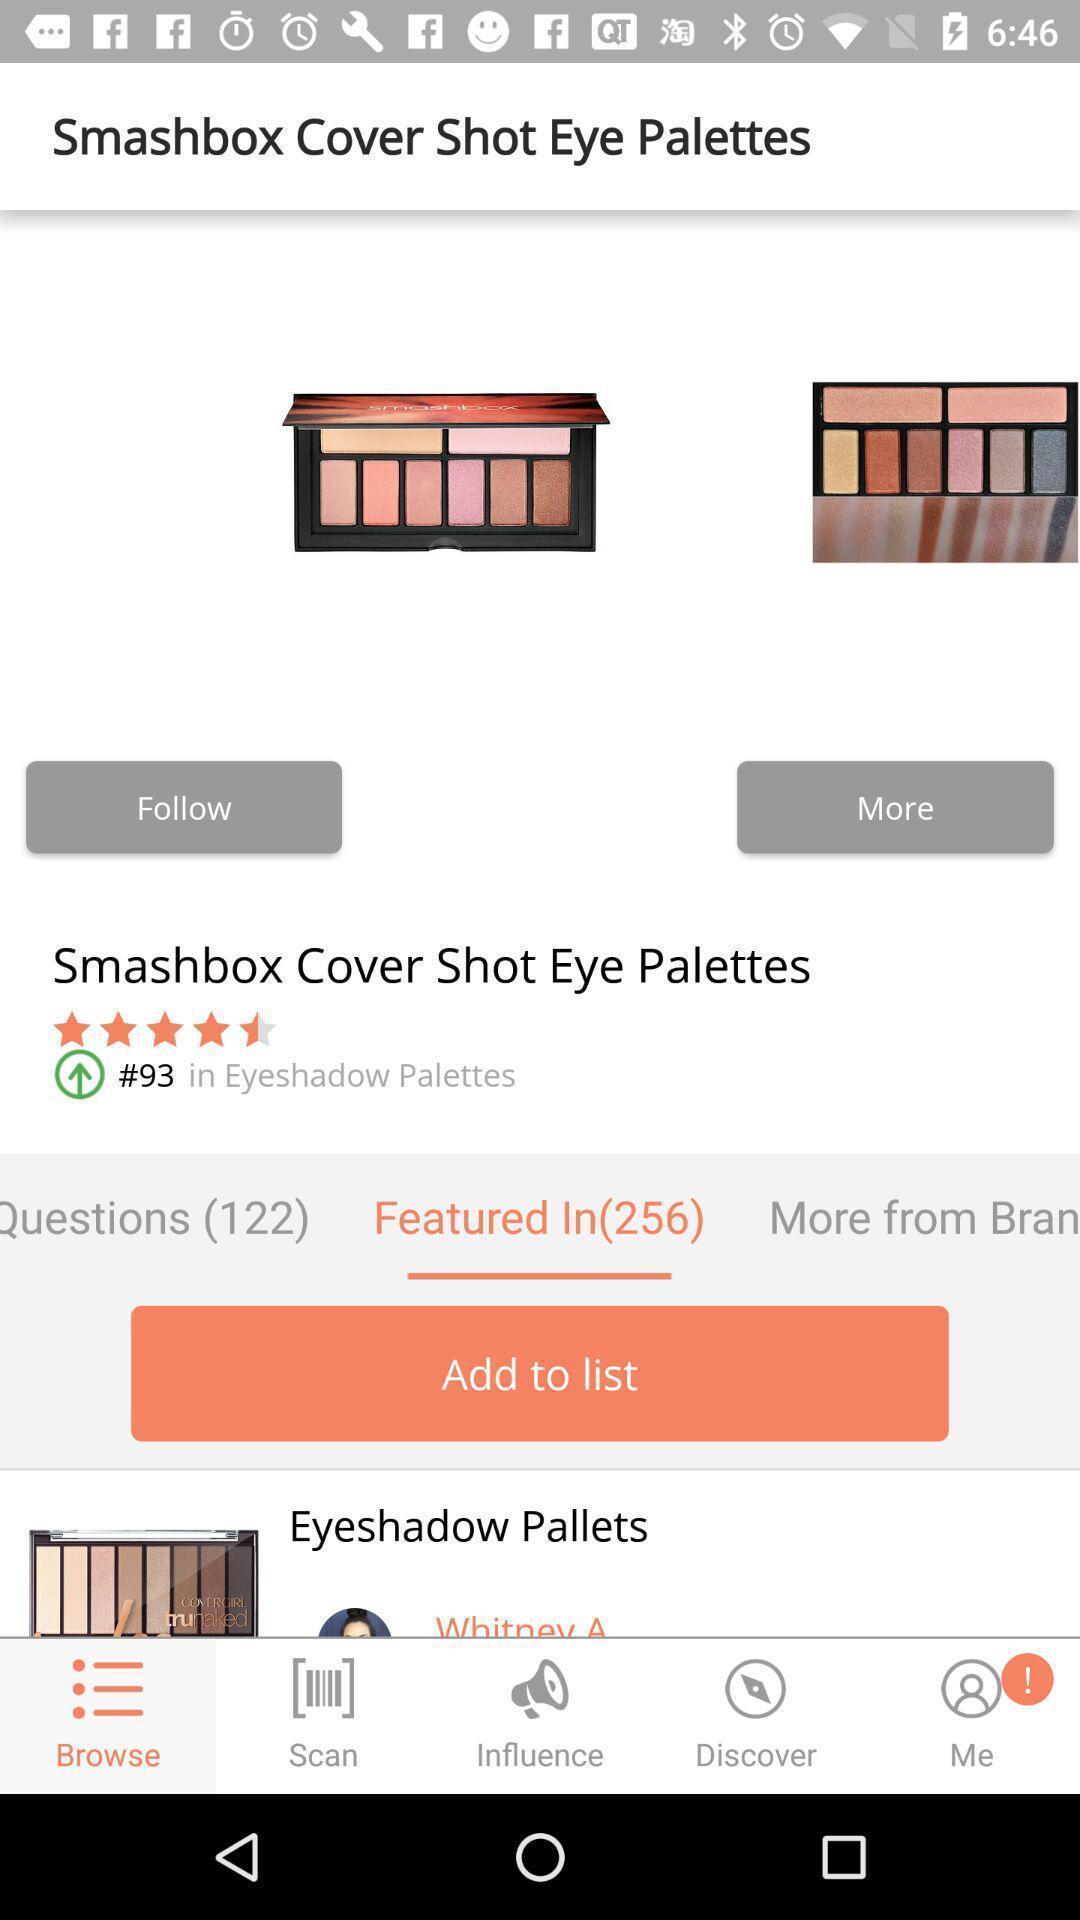What is the overall content of this screenshot? Shopping app displayed an item and other options. 